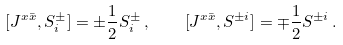Convert formula to latex. <formula><loc_0><loc_0><loc_500><loc_500>[ J ^ { x \bar { x } } , S ^ { \pm } _ { i } ] = \pm \frac { 1 } { 2 } S ^ { \pm } _ { i } \, , \quad [ J ^ { x \bar { x } } , S ^ { \pm i } ] = \mp \frac { 1 } { 2 } S ^ { \pm i } \, .</formula> 